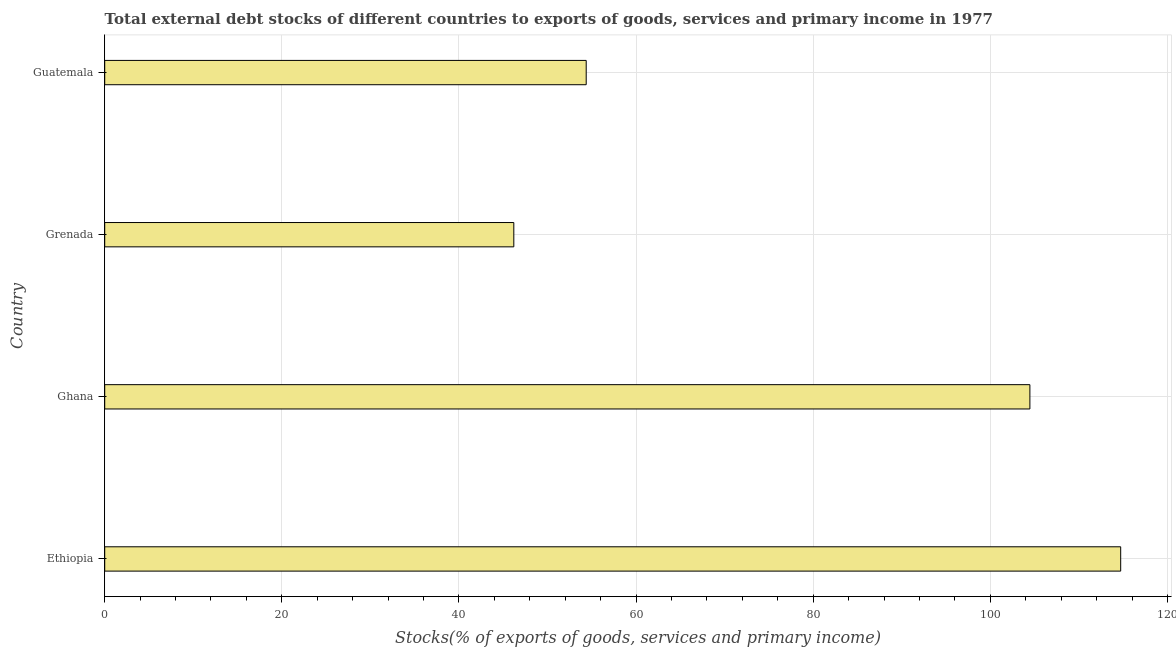Does the graph contain any zero values?
Offer a terse response. No. Does the graph contain grids?
Your answer should be compact. Yes. What is the title of the graph?
Provide a succinct answer. Total external debt stocks of different countries to exports of goods, services and primary income in 1977. What is the label or title of the X-axis?
Your response must be concise. Stocks(% of exports of goods, services and primary income). What is the external debt stocks in Grenada?
Keep it short and to the point. 46.19. Across all countries, what is the maximum external debt stocks?
Provide a short and direct response. 114.72. Across all countries, what is the minimum external debt stocks?
Offer a terse response. 46.19. In which country was the external debt stocks maximum?
Make the answer very short. Ethiopia. In which country was the external debt stocks minimum?
Ensure brevity in your answer.  Grenada. What is the sum of the external debt stocks?
Offer a terse response. 319.75. What is the difference between the external debt stocks in Ghana and Grenada?
Provide a short and direct response. 58.27. What is the average external debt stocks per country?
Your answer should be very brief. 79.94. What is the median external debt stocks?
Provide a short and direct response. 79.42. What is the ratio of the external debt stocks in Ethiopia to that in Grenada?
Your answer should be very brief. 2.48. Is the external debt stocks in Ghana less than that in Guatemala?
Offer a terse response. No. Is the difference between the external debt stocks in Ethiopia and Guatemala greater than the difference between any two countries?
Give a very brief answer. No. What is the difference between the highest and the second highest external debt stocks?
Offer a terse response. 10.25. What is the difference between the highest and the lowest external debt stocks?
Give a very brief answer. 68.53. Are all the bars in the graph horizontal?
Make the answer very short. Yes. How many countries are there in the graph?
Your response must be concise. 4. What is the difference between two consecutive major ticks on the X-axis?
Your answer should be very brief. 20. What is the Stocks(% of exports of goods, services and primary income) in Ethiopia?
Provide a succinct answer. 114.72. What is the Stocks(% of exports of goods, services and primary income) of Ghana?
Your answer should be very brief. 104.47. What is the Stocks(% of exports of goods, services and primary income) of Grenada?
Provide a succinct answer. 46.19. What is the Stocks(% of exports of goods, services and primary income) of Guatemala?
Your answer should be very brief. 54.37. What is the difference between the Stocks(% of exports of goods, services and primary income) in Ethiopia and Ghana?
Make the answer very short. 10.25. What is the difference between the Stocks(% of exports of goods, services and primary income) in Ethiopia and Grenada?
Offer a very short reply. 68.53. What is the difference between the Stocks(% of exports of goods, services and primary income) in Ethiopia and Guatemala?
Offer a very short reply. 60.35. What is the difference between the Stocks(% of exports of goods, services and primary income) in Ghana and Grenada?
Your answer should be very brief. 58.27. What is the difference between the Stocks(% of exports of goods, services and primary income) in Ghana and Guatemala?
Offer a very short reply. 50.1. What is the difference between the Stocks(% of exports of goods, services and primary income) in Grenada and Guatemala?
Make the answer very short. -8.17. What is the ratio of the Stocks(% of exports of goods, services and primary income) in Ethiopia to that in Ghana?
Give a very brief answer. 1.1. What is the ratio of the Stocks(% of exports of goods, services and primary income) in Ethiopia to that in Grenada?
Offer a very short reply. 2.48. What is the ratio of the Stocks(% of exports of goods, services and primary income) in Ethiopia to that in Guatemala?
Your answer should be compact. 2.11. What is the ratio of the Stocks(% of exports of goods, services and primary income) in Ghana to that in Grenada?
Make the answer very short. 2.26. What is the ratio of the Stocks(% of exports of goods, services and primary income) in Ghana to that in Guatemala?
Give a very brief answer. 1.92. What is the ratio of the Stocks(% of exports of goods, services and primary income) in Grenada to that in Guatemala?
Your answer should be compact. 0.85. 